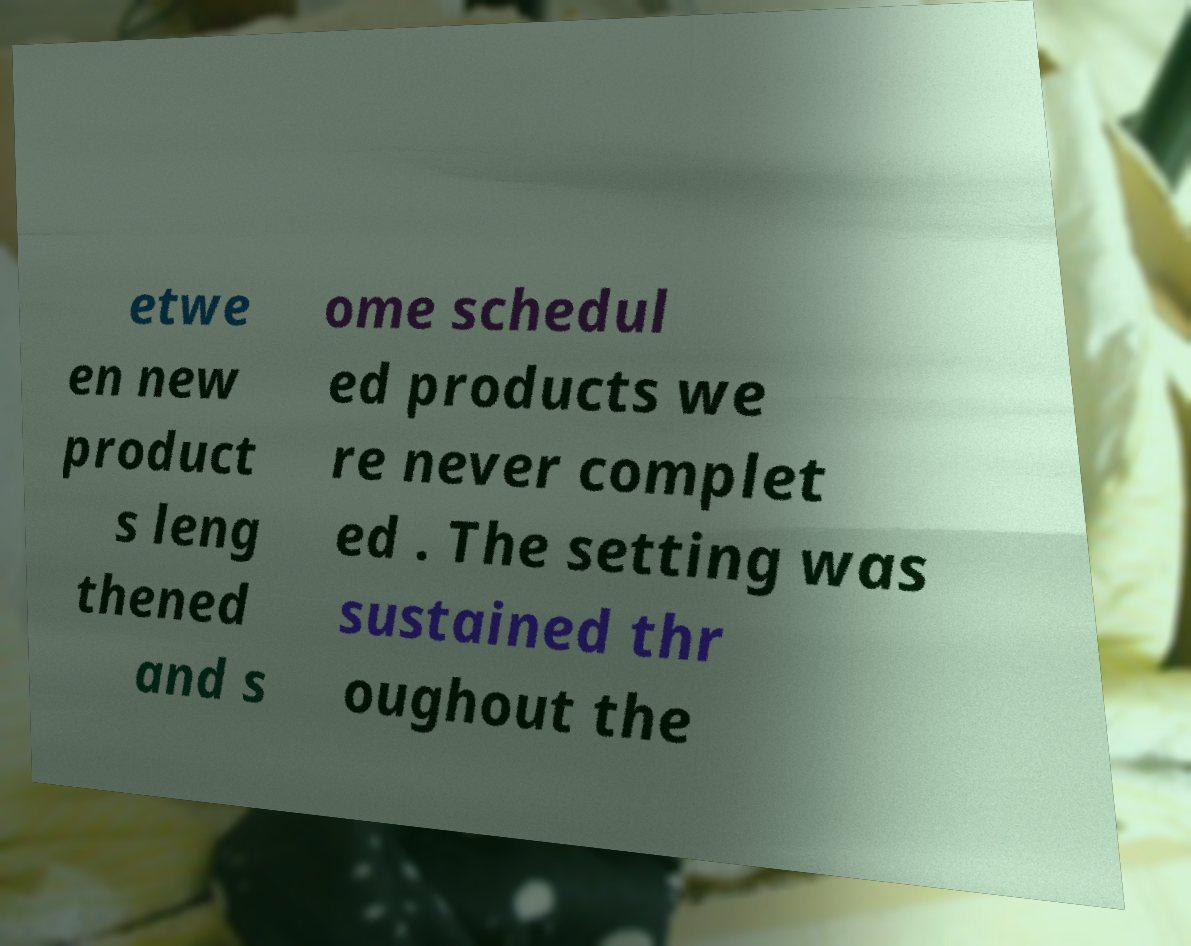Can you read and provide the text displayed in the image?This photo seems to have some interesting text. Can you extract and type it out for me? etwe en new product s leng thened and s ome schedul ed products we re never complet ed . The setting was sustained thr oughout the 